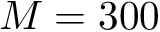Convert formula to latex. <formula><loc_0><loc_0><loc_500><loc_500>M = 3 0 0</formula> 